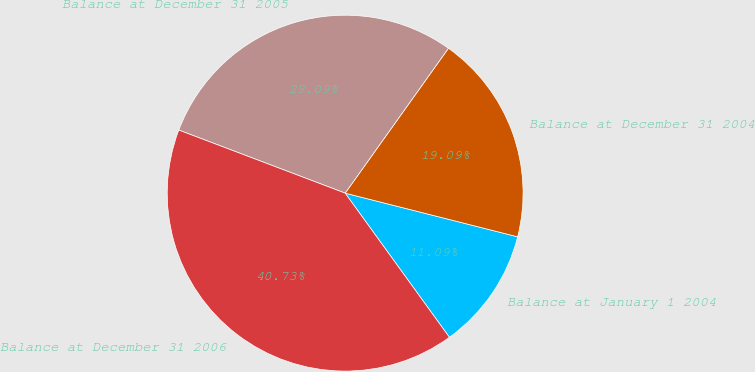Convert chart to OTSL. <chart><loc_0><loc_0><loc_500><loc_500><pie_chart><fcel>Balance at January 1 2004<fcel>Balance at December 31 2004<fcel>Balance at December 31 2005<fcel>Balance at December 31 2006<nl><fcel>11.09%<fcel>19.09%<fcel>29.09%<fcel>40.73%<nl></chart> 